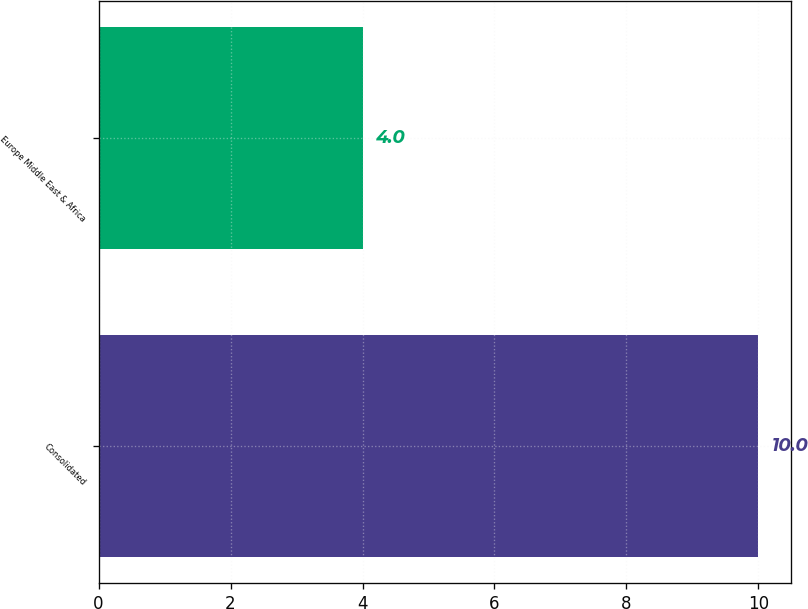<chart> <loc_0><loc_0><loc_500><loc_500><bar_chart><fcel>Consolidated<fcel>Europe Middle East & Africa<nl><fcel>10<fcel>4<nl></chart> 